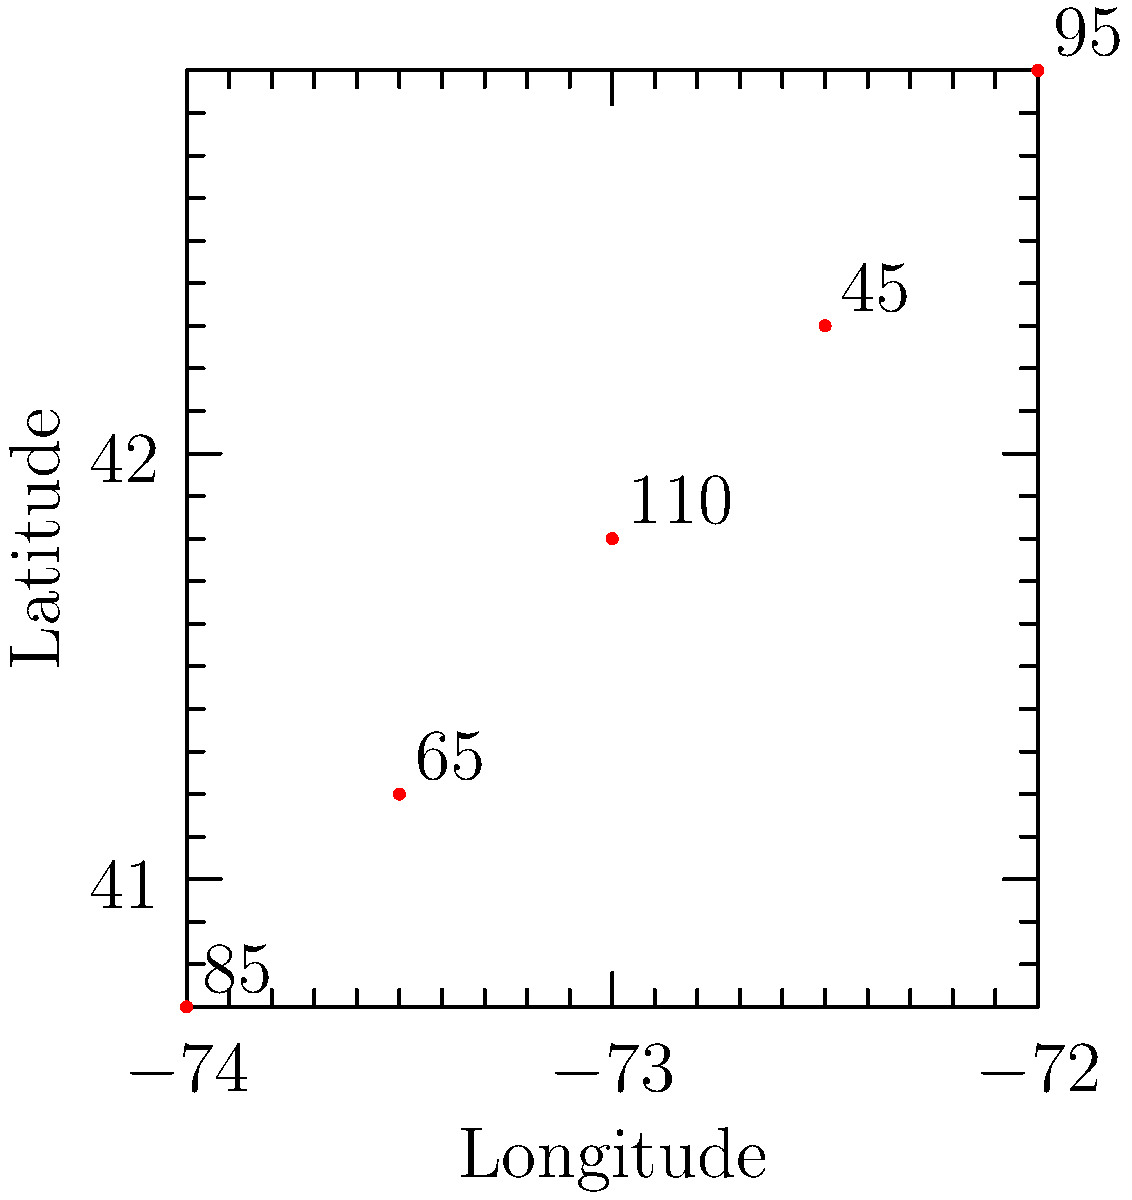As an environmental science major, you're tasked with analyzing air quality data across different locations. The graph shows Air Quality Index (AQI) values plotted on a coordinate system using latitude and longitude. Which location has the highest AQI value, and what does this indicate about the air quality there compared to other points in the "Mario Kart race track" of data? To answer this question, we need to follow these steps:

1. Examine the graph to identify the AQI values for each point:
   - (-74.0, 40.7): AQI 85
   - (-73.5, 41.2): AQI 65
   - (-73.0, 41.8): AQI 110
   - (-72.5, 42.3): AQI 45
   - (-72.0, 42.9): AQI 95

2. Identify the highest AQI value:
   The highest AQI value is 110, located at coordinates (-73.0, 41.8).

3. Interpret the AQI value:
   - AQI values range from 0 to 500.
   - Higher AQI values indicate worse air quality.
   - AQI 110 falls in the "Unhealthy for Sensitive Groups" category (101-150).

4. Compare to other points:
   - The location with AQI 110 has significantly worse air quality than the others.
   - Other locations range from "Good" (0-50) to "Moderate" (51-100) air quality.

5. "Mario Kart race track" analogy:
   - If we imagine the data points as a race track, the point with AQI 110 would be like a challenging obstacle or hazard in the game, representing a area of concern for air quality.

Therefore, the location at (-73.0, 41.8) has the highest AQI value of 110, indicating unhealthy air quality for sensitive groups and representing the most polluted area in this dataset.
Answer: (-73.0, 41.8) with AQI 110; unhealthy for sensitive groups 